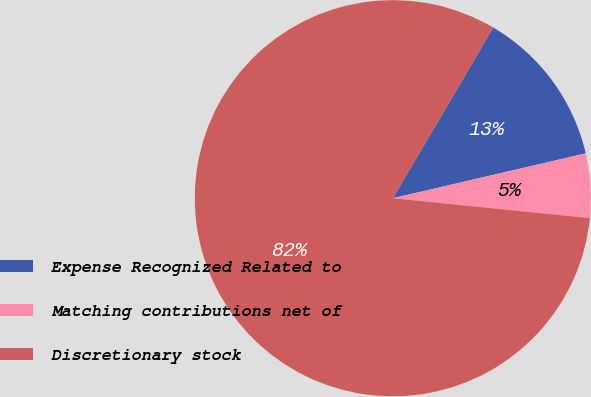Convert chart to OTSL. <chart><loc_0><loc_0><loc_500><loc_500><pie_chart><fcel>Expense Recognized Related to<fcel>Matching contributions net of<fcel>Discretionary stock<nl><fcel>12.9%<fcel>5.24%<fcel>81.86%<nl></chart> 